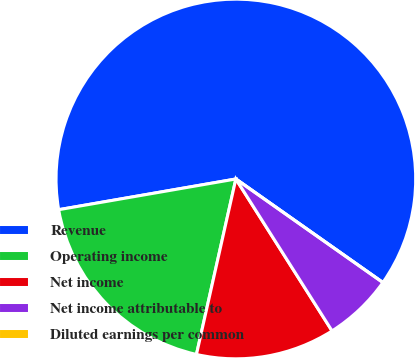Convert chart. <chart><loc_0><loc_0><loc_500><loc_500><pie_chart><fcel>Revenue<fcel>Operating income<fcel>Net income<fcel>Net income attributable to<fcel>Diluted earnings per common<nl><fcel>62.49%<fcel>18.75%<fcel>12.5%<fcel>6.25%<fcel>0.0%<nl></chart> 